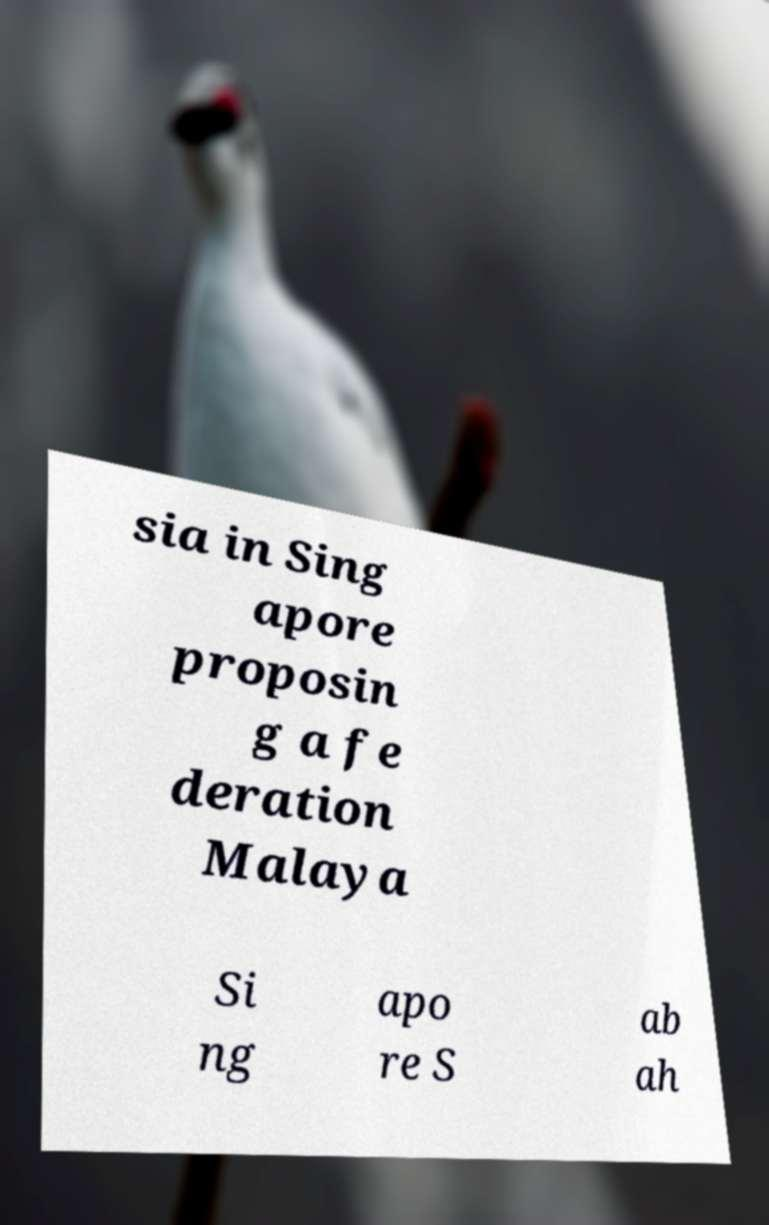For documentation purposes, I need the text within this image transcribed. Could you provide that? sia in Sing apore proposin g a fe deration Malaya Si ng apo re S ab ah 